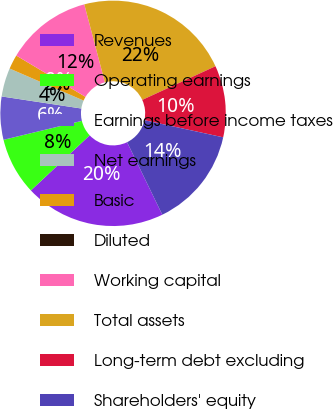Convert chart to OTSL. <chart><loc_0><loc_0><loc_500><loc_500><pie_chart><fcel>Revenues<fcel>Operating earnings<fcel>Earnings before income taxes<fcel>Net earnings<fcel>Basic<fcel>Diluted<fcel>Working capital<fcel>Total assets<fcel>Long-term debt excluding<fcel>Shareholders' equity<nl><fcel>20.2%<fcel>8.22%<fcel>6.17%<fcel>4.11%<fcel>2.06%<fcel>0.0%<fcel>12.33%<fcel>22.25%<fcel>10.28%<fcel>14.39%<nl></chart> 